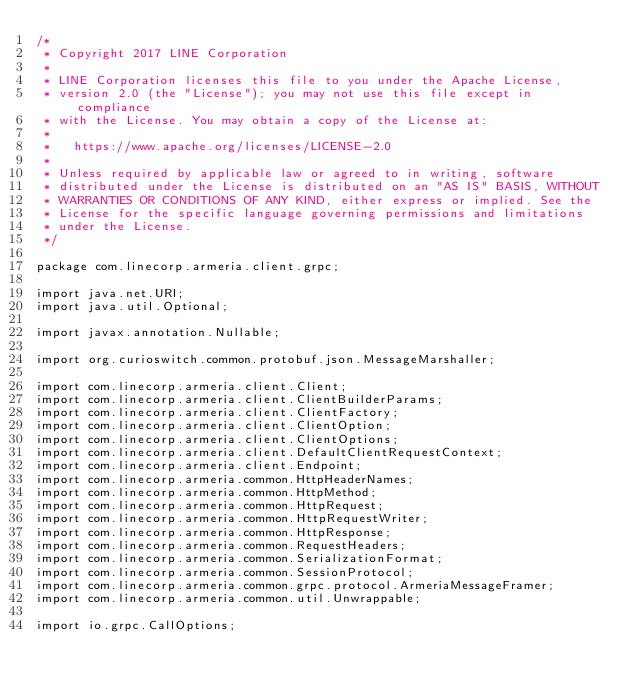<code> <loc_0><loc_0><loc_500><loc_500><_Java_>/*
 * Copyright 2017 LINE Corporation
 *
 * LINE Corporation licenses this file to you under the Apache License,
 * version 2.0 (the "License"); you may not use this file except in compliance
 * with the License. You may obtain a copy of the License at:
 *
 *   https://www.apache.org/licenses/LICENSE-2.0
 *
 * Unless required by applicable law or agreed to in writing, software
 * distributed under the License is distributed on an "AS IS" BASIS, WITHOUT
 * WARRANTIES OR CONDITIONS OF ANY KIND, either express or implied. See the
 * License for the specific language governing permissions and limitations
 * under the License.
 */

package com.linecorp.armeria.client.grpc;

import java.net.URI;
import java.util.Optional;

import javax.annotation.Nullable;

import org.curioswitch.common.protobuf.json.MessageMarshaller;

import com.linecorp.armeria.client.Client;
import com.linecorp.armeria.client.ClientBuilderParams;
import com.linecorp.armeria.client.ClientFactory;
import com.linecorp.armeria.client.ClientOption;
import com.linecorp.armeria.client.ClientOptions;
import com.linecorp.armeria.client.DefaultClientRequestContext;
import com.linecorp.armeria.client.Endpoint;
import com.linecorp.armeria.common.HttpHeaderNames;
import com.linecorp.armeria.common.HttpMethod;
import com.linecorp.armeria.common.HttpRequest;
import com.linecorp.armeria.common.HttpRequestWriter;
import com.linecorp.armeria.common.HttpResponse;
import com.linecorp.armeria.common.RequestHeaders;
import com.linecorp.armeria.common.SerializationFormat;
import com.linecorp.armeria.common.SessionProtocol;
import com.linecorp.armeria.common.grpc.protocol.ArmeriaMessageFramer;
import com.linecorp.armeria.common.util.Unwrappable;

import io.grpc.CallOptions;</code> 